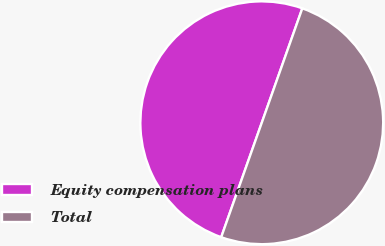<chart> <loc_0><loc_0><loc_500><loc_500><pie_chart><fcel>Equity compensation plans<fcel>Total<nl><fcel>50.0%<fcel>50.0%<nl></chart> 